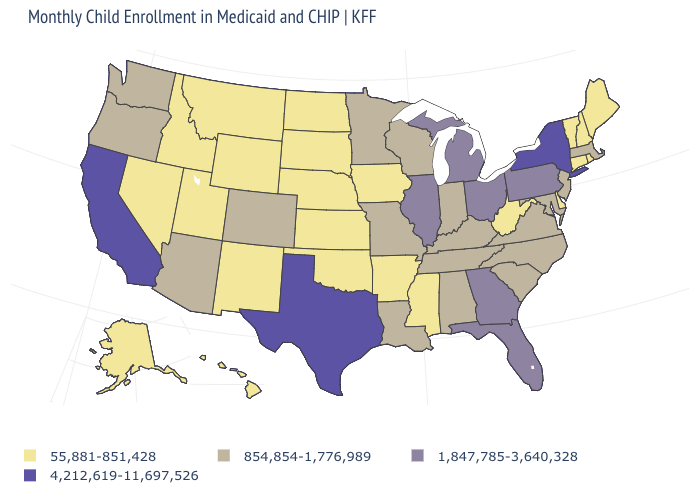What is the lowest value in the West?
Quick response, please. 55,881-851,428. Does Arizona have a higher value than Hawaii?
Concise answer only. Yes. What is the lowest value in the West?
Keep it brief. 55,881-851,428. What is the value of Maine?
Concise answer only. 55,881-851,428. What is the value of Connecticut?
Quick response, please. 55,881-851,428. Name the states that have a value in the range 4,212,619-11,697,526?
Concise answer only. California, New York, Texas. What is the lowest value in the USA?
Be succinct. 55,881-851,428. What is the highest value in states that border Massachusetts?
Write a very short answer. 4,212,619-11,697,526. What is the lowest value in states that border Montana?
Short answer required. 55,881-851,428. Does the map have missing data?
Concise answer only. No. Does Arizona have the lowest value in the West?
Keep it brief. No. Among the states that border Wisconsin , which have the lowest value?
Concise answer only. Iowa. What is the value of Washington?
Concise answer only. 854,854-1,776,989. Name the states that have a value in the range 4,212,619-11,697,526?
Short answer required. California, New York, Texas. Does Wyoming have the highest value in the West?
Be succinct. No. 